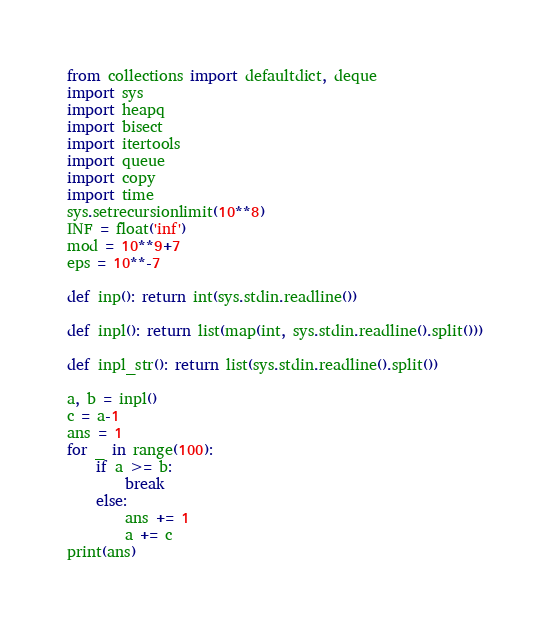Convert code to text. <code><loc_0><loc_0><loc_500><loc_500><_Python_>from collections import defaultdict, deque
import sys
import heapq
import bisect
import itertools
import queue
import copy
import time
sys.setrecursionlimit(10**8)
INF = float('inf')
mod = 10**9+7
eps = 10**-7

def inp(): return int(sys.stdin.readline())

def inpl(): return list(map(int, sys.stdin.readline().split()))

def inpl_str(): return list(sys.stdin.readline().split())

a, b = inpl()
c = a-1
ans = 1
for _ in range(100):
    if a >= b:
        break
    else:
        ans += 1
        a += c
print(ans)</code> 